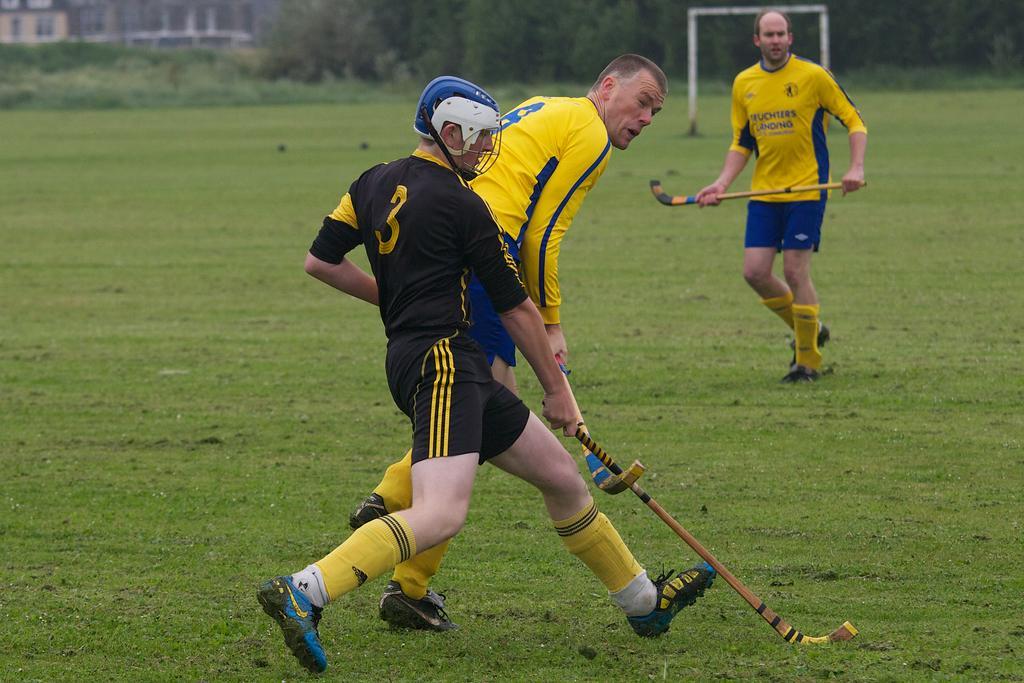Can you describe this image briefly? In this image there are three people wearing sports dress and are holding a hockey stick, in the background there are trees, net and a building. 